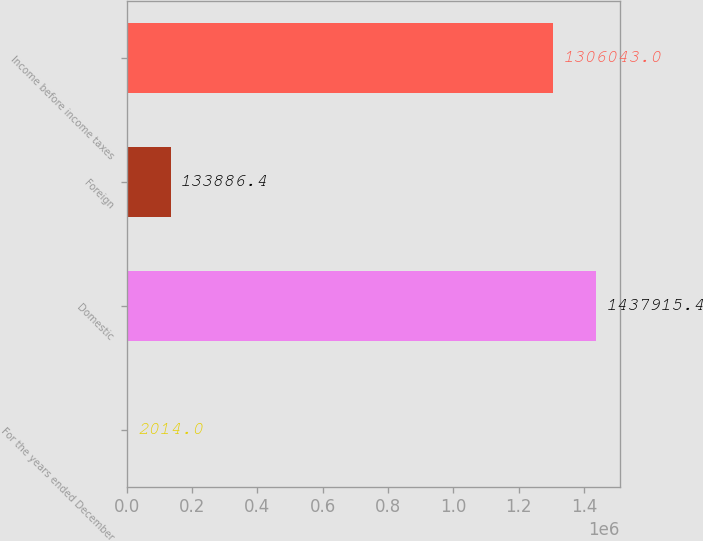<chart> <loc_0><loc_0><loc_500><loc_500><bar_chart><fcel>For the years ended December<fcel>Domestic<fcel>Foreign<fcel>Income before income taxes<nl><fcel>2014<fcel>1.43792e+06<fcel>133886<fcel>1.30604e+06<nl></chart> 